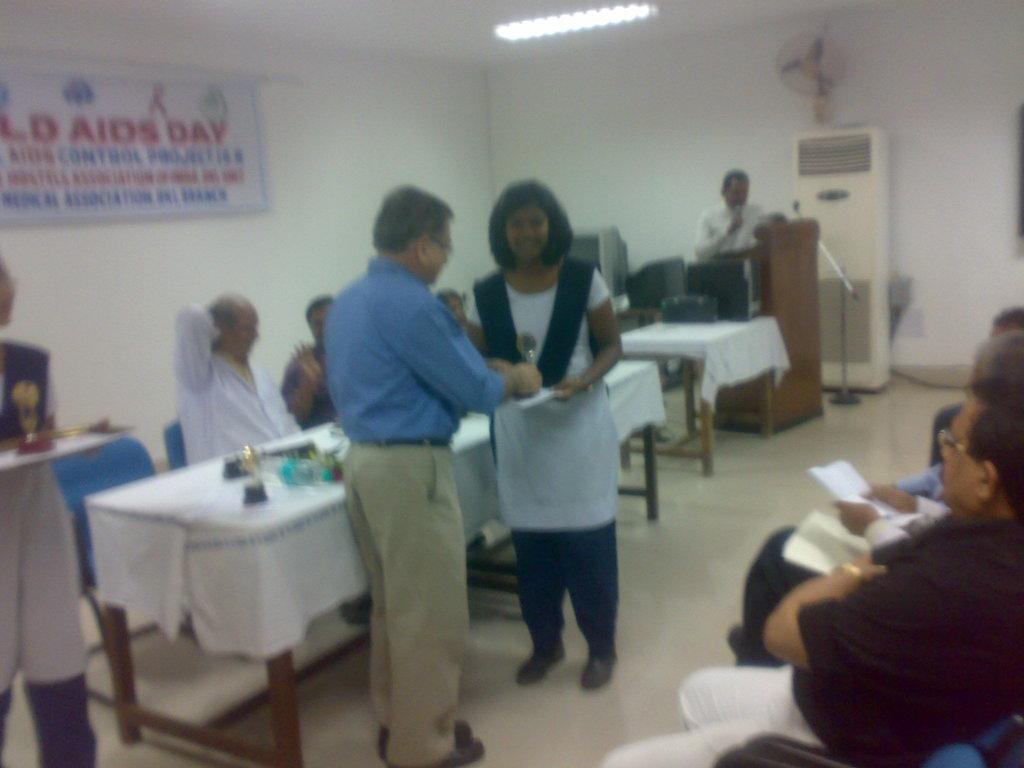Describe this image in one or two sentences. in a room there are some people conducting medical camp in which some people are sitting and some people are standing. 